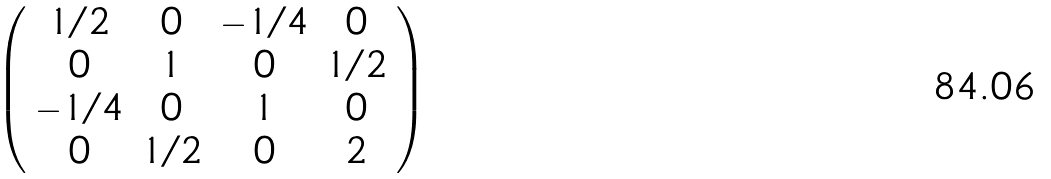Convert formula to latex. <formula><loc_0><loc_0><loc_500><loc_500>\left ( \begin{array} { c c c c } 1 / 2 & 0 & - 1 / 4 & 0 \\ 0 & 1 & 0 & 1 / 2 \\ - 1 / 4 & 0 & 1 & 0 \\ 0 & 1 / 2 & 0 & 2 \end{array} \right )</formula> 